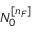Convert formula to latex. <formula><loc_0><loc_0><loc_500><loc_500>N _ { 0 } ^ { [ n _ { F } ] }</formula> 